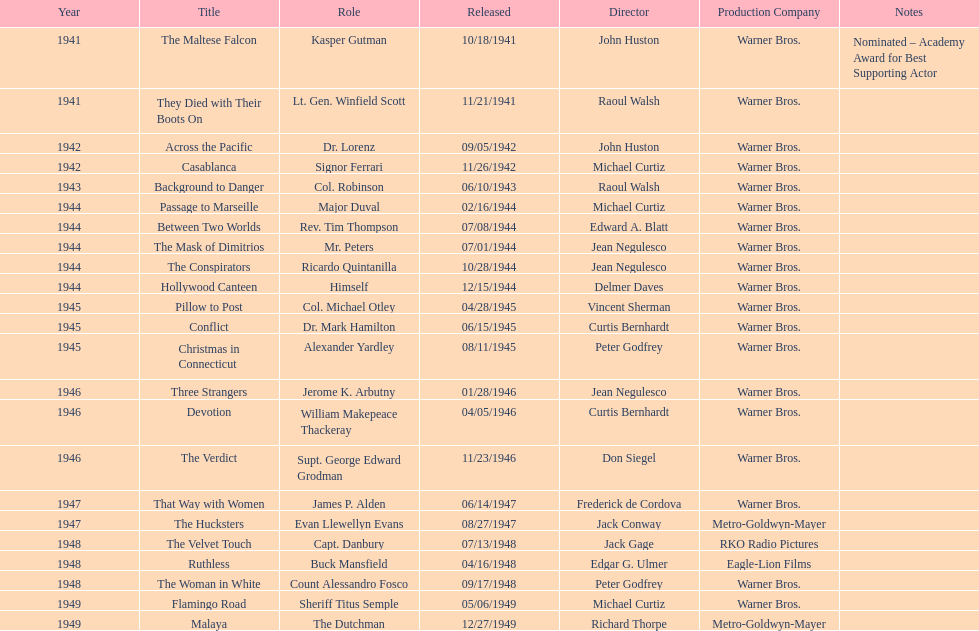How long did sydney greenstreet's acting career last? 9 years. 